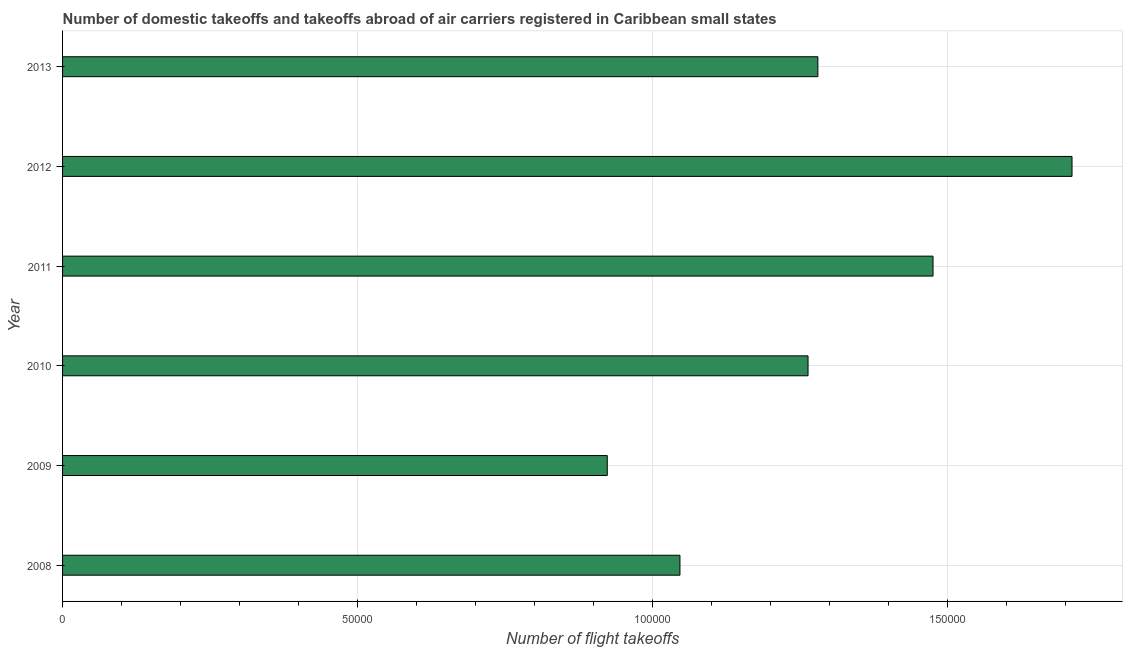What is the title of the graph?
Keep it short and to the point. Number of domestic takeoffs and takeoffs abroad of air carriers registered in Caribbean small states. What is the label or title of the X-axis?
Keep it short and to the point. Number of flight takeoffs. What is the number of flight takeoffs in 2012?
Your response must be concise. 1.71e+05. Across all years, what is the maximum number of flight takeoffs?
Give a very brief answer. 1.71e+05. Across all years, what is the minimum number of flight takeoffs?
Make the answer very short. 9.23e+04. In which year was the number of flight takeoffs minimum?
Ensure brevity in your answer.  2009. What is the sum of the number of flight takeoffs?
Give a very brief answer. 7.70e+05. What is the difference between the number of flight takeoffs in 2008 and 2012?
Provide a succinct answer. -6.64e+04. What is the average number of flight takeoffs per year?
Ensure brevity in your answer.  1.28e+05. What is the median number of flight takeoffs?
Offer a very short reply. 1.27e+05. What is the ratio of the number of flight takeoffs in 2011 to that in 2012?
Your answer should be compact. 0.86. Is the number of flight takeoffs in 2010 less than that in 2013?
Offer a terse response. Yes. Is the difference between the number of flight takeoffs in 2010 and 2012 greater than the difference between any two years?
Offer a very short reply. No. What is the difference between the highest and the second highest number of flight takeoffs?
Provide a short and direct response. 2.36e+04. What is the difference between the highest and the lowest number of flight takeoffs?
Your answer should be compact. 7.87e+04. In how many years, is the number of flight takeoffs greater than the average number of flight takeoffs taken over all years?
Make the answer very short. 2. How many years are there in the graph?
Give a very brief answer. 6. Are the values on the major ticks of X-axis written in scientific E-notation?
Your answer should be compact. No. What is the Number of flight takeoffs in 2008?
Offer a very short reply. 1.05e+05. What is the Number of flight takeoffs in 2009?
Keep it short and to the point. 9.23e+04. What is the Number of flight takeoffs of 2010?
Your answer should be very brief. 1.26e+05. What is the Number of flight takeoffs of 2011?
Your response must be concise. 1.47e+05. What is the Number of flight takeoffs in 2012?
Provide a short and direct response. 1.71e+05. What is the Number of flight takeoffs in 2013?
Keep it short and to the point. 1.28e+05. What is the difference between the Number of flight takeoffs in 2008 and 2009?
Your response must be concise. 1.23e+04. What is the difference between the Number of flight takeoffs in 2008 and 2010?
Provide a succinct answer. -2.17e+04. What is the difference between the Number of flight takeoffs in 2008 and 2011?
Offer a very short reply. -4.29e+04. What is the difference between the Number of flight takeoffs in 2008 and 2012?
Provide a short and direct response. -6.64e+04. What is the difference between the Number of flight takeoffs in 2008 and 2013?
Ensure brevity in your answer.  -2.34e+04. What is the difference between the Number of flight takeoffs in 2009 and 2010?
Give a very brief answer. -3.40e+04. What is the difference between the Number of flight takeoffs in 2009 and 2011?
Provide a short and direct response. -5.52e+04. What is the difference between the Number of flight takeoffs in 2009 and 2012?
Give a very brief answer. -7.87e+04. What is the difference between the Number of flight takeoffs in 2009 and 2013?
Your answer should be compact. -3.57e+04. What is the difference between the Number of flight takeoffs in 2010 and 2011?
Provide a succinct answer. -2.12e+04. What is the difference between the Number of flight takeoffs in 2010 and 2012?
Give a very brief answer. -4.47e+04. What is the difference between the Number of flight takeoffs in 2010 and 2013?
Offer a terse response. -1665.01. What is the difference between the Number of flight takeoffs in 2011 and 2012?
Your response must be concise. -2.36e+04. What is the difference between the Number of flight takeoffs in 2011 and 2013?
Offer a very short reply. 1.95e+04. What is the difference between the Number of flight takeoffs in 2012 and 2013?
Make the answer very short. 4.31e+04. What is the ratio of the Number of flight takeoffs in 2008 to that in 2009?
Provide a short and direct response. 1.13. What is the ratio of the Number of flight takeoffs in 2008 to that in 2010?
Ensure brevity in your answer.  0.83. What is the ratio of the Number of flight takeoffs in 2008 to that in 2011?
Your answer should be very brief. 0.71. What is the ratio of the Number of flight takeoffs in 2008 to that in 2012?
Keep it short and to the point. 0.61. What is the ratio of the Number of flight takeoffs in 2008 to that in 2013?
Your response must be concise. 0.82. What is the ratio of the Number of flight takeoffs in 2009 to that in 2010?
Offer a terse response. 0.73. What is the ratio of the Number of flight takeoffs in 2009 to that in 2011?
Your answer should be very brief. 0.63. What is the ratio of the Number of flight takeoffs in 2009 to that in 2012?
Ensure brevity in your answer.  0.54. What is the ratio of the Number of flight takeoffs in 2009 to that in 2013?
Offer a terse response. 0.72. What is the ratio of the Number of flight takeoffs in 2010 to that in 2011?
Give a very brief answer. 0.86. What is the ratio of the Number of flight takeoffs in 2010 to that in 2012?
Make the answer very short. 0.74. What is the ratio of the Number of flight takeoffs in 2010 to that in 2013?
Your response must be concise. 0.99. What is the ratio of the Number of flight takeoffs in 2011 to that in 2012?
Your answer should be very brief. 0.86. What is the ratio of the Number of flight takeoffs in 2011 to that in 2013?
Your answer should be compact. 1.15. What is the ratio of the Number of flight takeoffs in 2012 to that in 2013?
Your answer should be very brief. 1.34. 